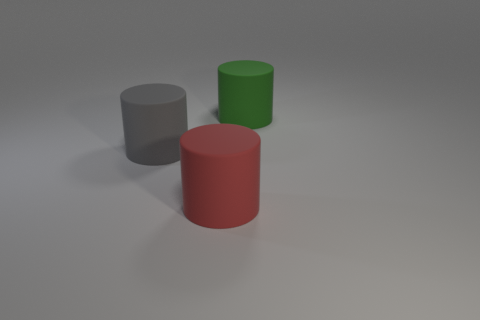Subtract all red cylinders. How many cylinders are left? 2 Add 2 large blue spheres. How many objects exist? 5 Subtract all green cylinders. How many cylinders are left? 2 Subtract 1 cylinders. How many cylinders are left? 2 Subtract all small gray rubber things. Subtract all large matte cylinders. How many objects are left? 0 Add 3 big gray objects. How many big gray objects are left? 4 Add 1 tiny brown metal blocks. How many tiny brown metal blocks exist? 1 Subtract 1 green cylinders. How many objects are left? 2 Subtract all brown cylinders. Subtract all red blocks. How many cylinders are left? 3 Subtract all yellow spheres. How many gray cylinders are left? 1 